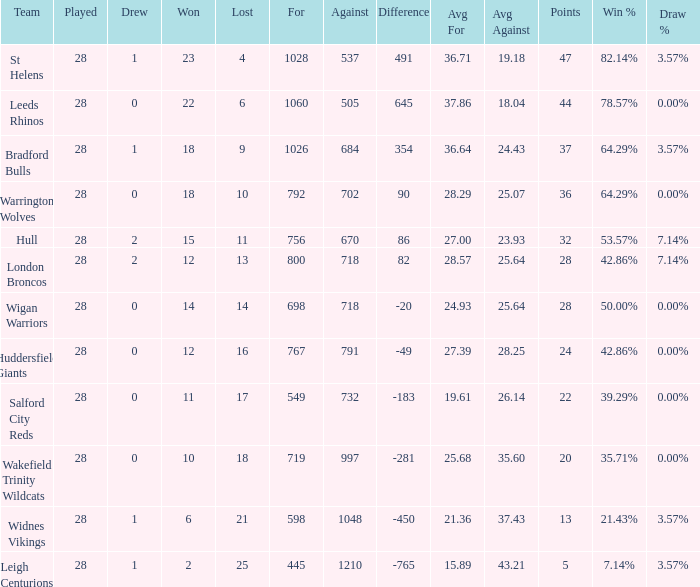What is the average points for a team that lost 4 and played more than 28 games? None. 